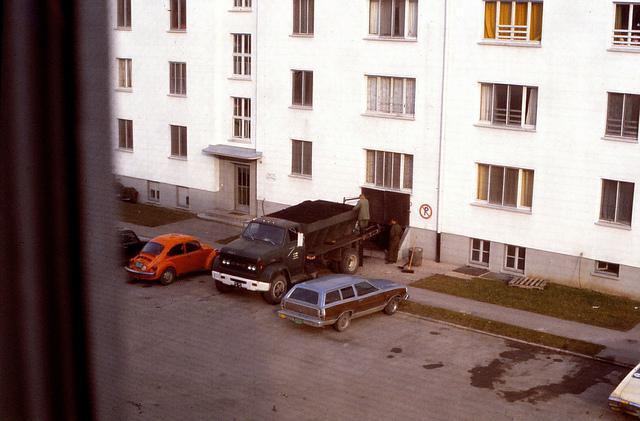How many cars are there?
Give a very brief answer. 2. 